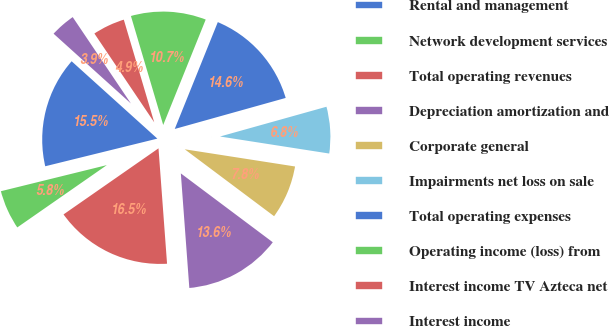Convert chart to OTSL. <chart><loc_0><loc_0><loc_500><loc_500><pie_chart><fcel>Rental and management<fcel>Network development services<fcel>Total operating revenues<fcel>Depreciation amortization and<fcel>Corporate general<fcel>Impairments net loss on sale<fcel>Total operating expenses<fcel>Operating income (loss) from<fcel>Interest income TV Azteca net<fcel>Interest income<nl><fcel>15.53%<fcel>5.83%<fcel>16.5%<fcel>13.59%<fcel>7.77%<fcel>6.8%<fcel>14.56%<fcel>10.68%<fcel>4.85%<fcel>3.88%<nl></chart> 